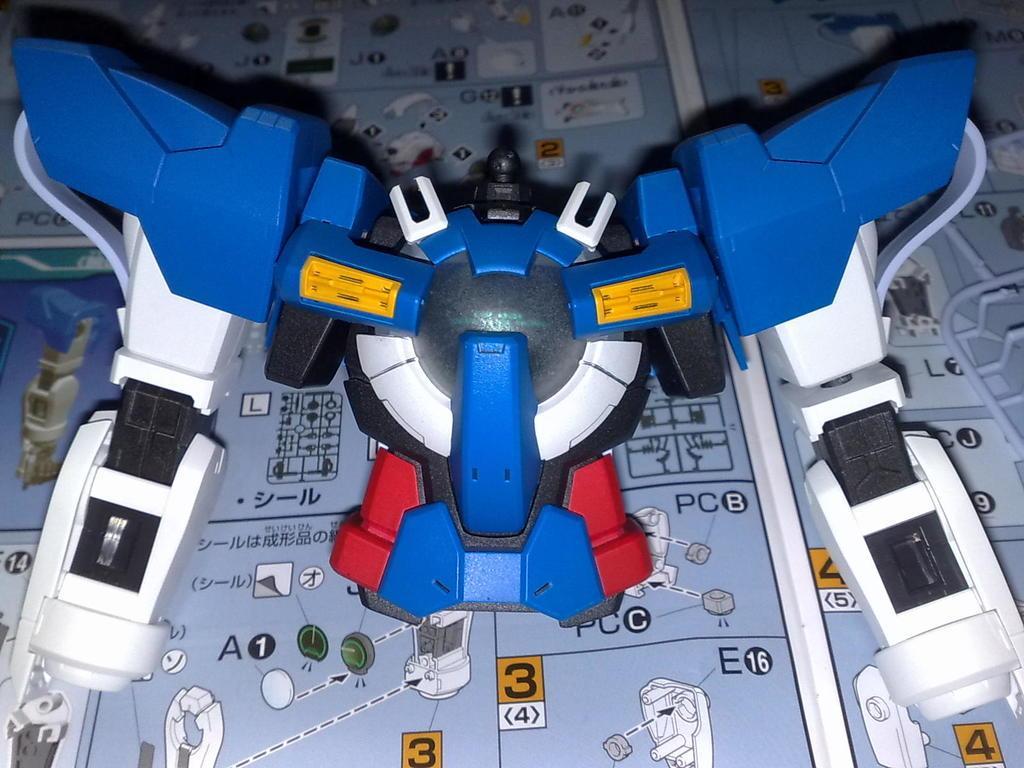Can you describe this image briefly? In this image I can see a blue and white colour thing. In background I can see something is written at few places. 